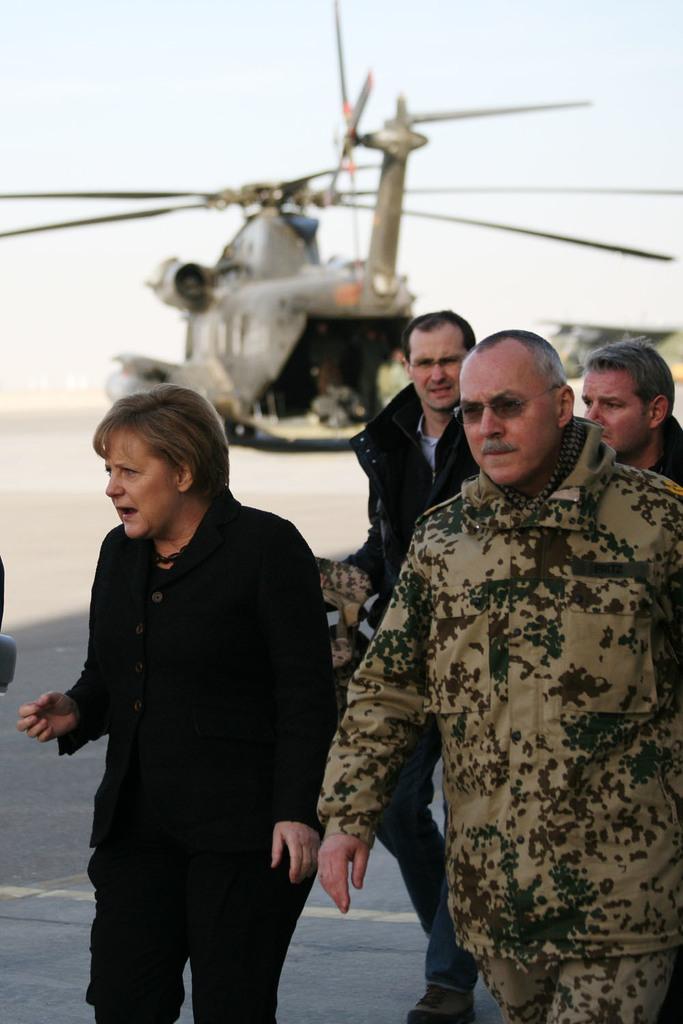In one or two sentences, can you explain what this image depicts? In the foreground of the image we can see some people are walking. On the top of the image we can see a helicopter, but it is in a blur. 